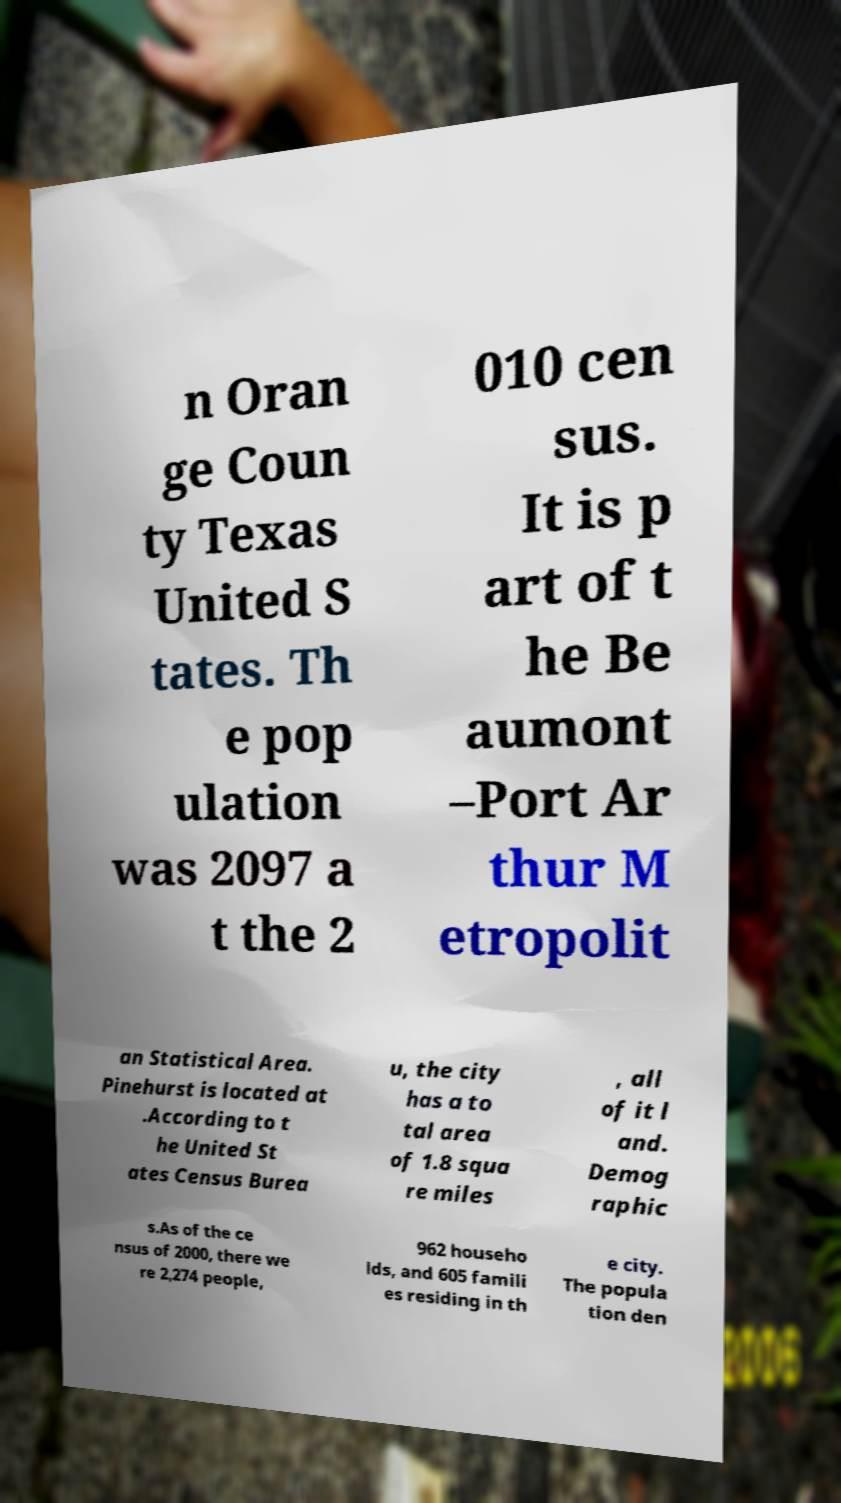Please identify and transcribe the text found in this image. n Oran ge Coun ty Texas United S tates. Th e pop ulation was 2097 a t the 2 010 cen sus. It is p art of t he Be aumont –Port Ar thur M etropolit an Statistical Area. Pinehurst is located at .According to t he United St ates Census Burea u, the city has a to tal area of 1.8 squa re miles , all of it l and. Demog raphic s.As of the ce nsus of 2000, there we re 2,274 people, 962 househo lds, and 605 famili es residing in th e city. The popula tion den 